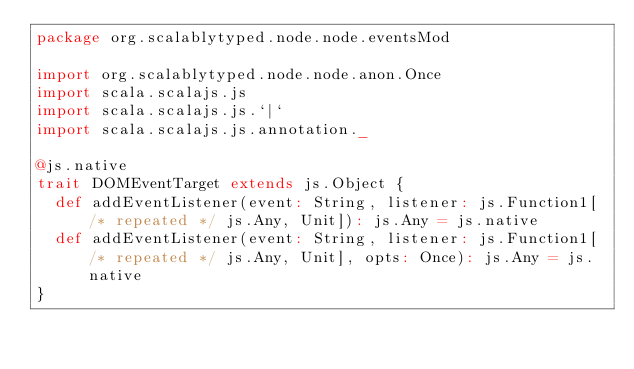Convert code to text. <code><loc_0><loc_0><loc_500><loc_500><_Scala_>package org.scalablytyped.node.node.eventsMod

import org.scalablytyped.node.node.anon.Once
import scala.scalajs.js
import scala.scalajs.js.`|`
import scala.scalajs.js.annotation._

@js.native
trait DOMEventTarget extends js.Object {
  def addEventListener(event: String, listener: js.Function1[/* repeated */ js.Any, Unit]): js.Any = js.native
  def addEventListener(event: String, listener: js.Function1[/* repeated */ js.Any, Unit], opts: Once): js.Any = js.native
}

</code> 